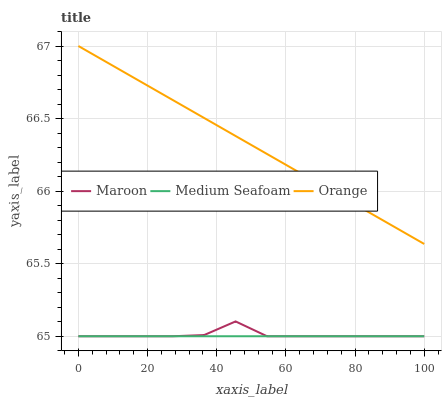Does Medium Seafoam have the minimum area under the curve?
Answer yes or no. Yes. Does Orange have the maximum area under the curve?
Answer yes or no. Yes. Does Maroon have the minimum area under the curve?
Answer yes or no. No. Does Maroon have the maximum area under the curve?
Answer yes or no. No. Is Medium Seafoam the smoothest?
Answer yes or no. Yes. Is Maroon the roughest?
Answer yes or no. Yes. Is Maroon the smoothest?
Answer yes or no. No. Is Medium Seafoam the roughest?
Answer yes or no. No. Does Medium Seafoam have the lowest value?
Answer yes or no. Yes. Does Orange have the highest value?
Answer yes or no. Yes. Does Maroon have the highest value?
Answer yes or no. No. Is Medium Seafoam less than Orange?
Answer yes or no. Yes. Is Orange greater than Medium Seafoam?
Answer yes or no. Yes. Does Maroon intersect Medium Seafoam?
Answer yes or no. Yes. Is Maroon less than Medium Seafoam?
Answer yes or no. No. Is Maroon greater than Medium Seafoam?
Answer yes or no. No. Does Medium Seafoam intersect Orange?
Answer yes or no. No. 